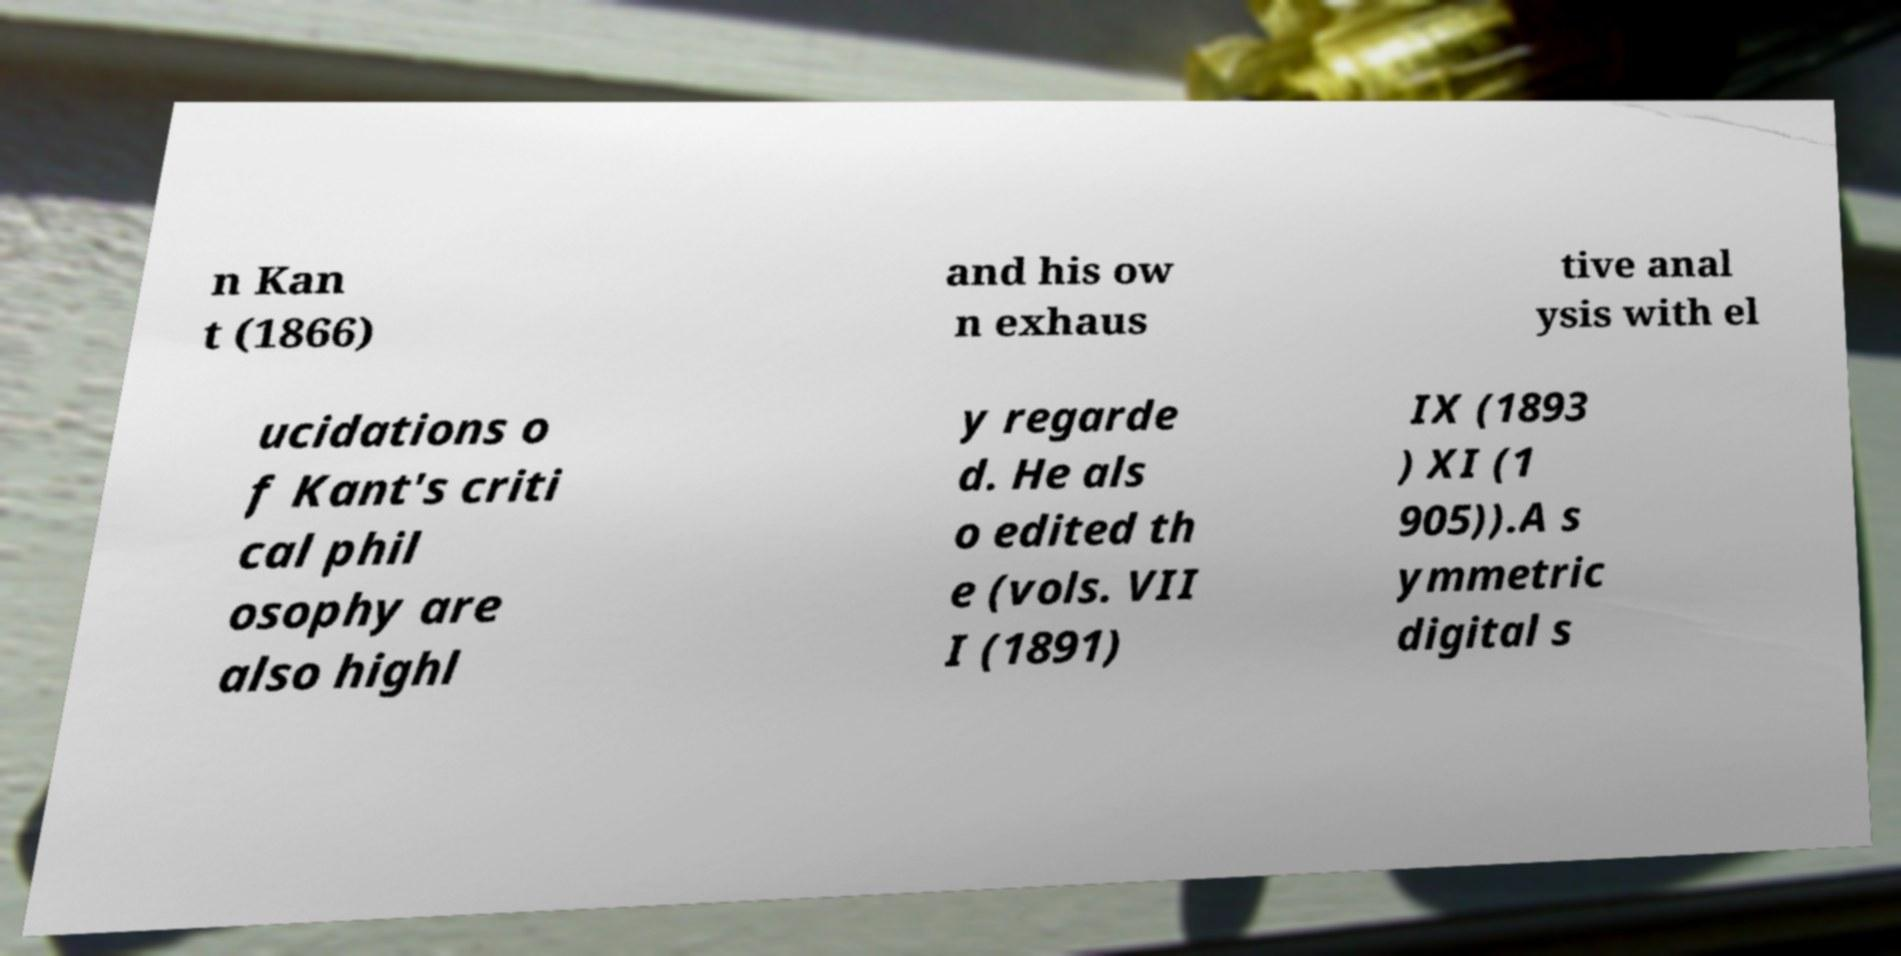Please identify and transcribe the text found in this image. n Kan t (1866) and his ow n exhaus tive anal ysis with el ucidations o f Kant's criti cal phil osophy are also highl y regarde d. He als o edited th e (vols. VII I (1891) IX (1893 ) XI (1 905)).A s ymmetric digital s 